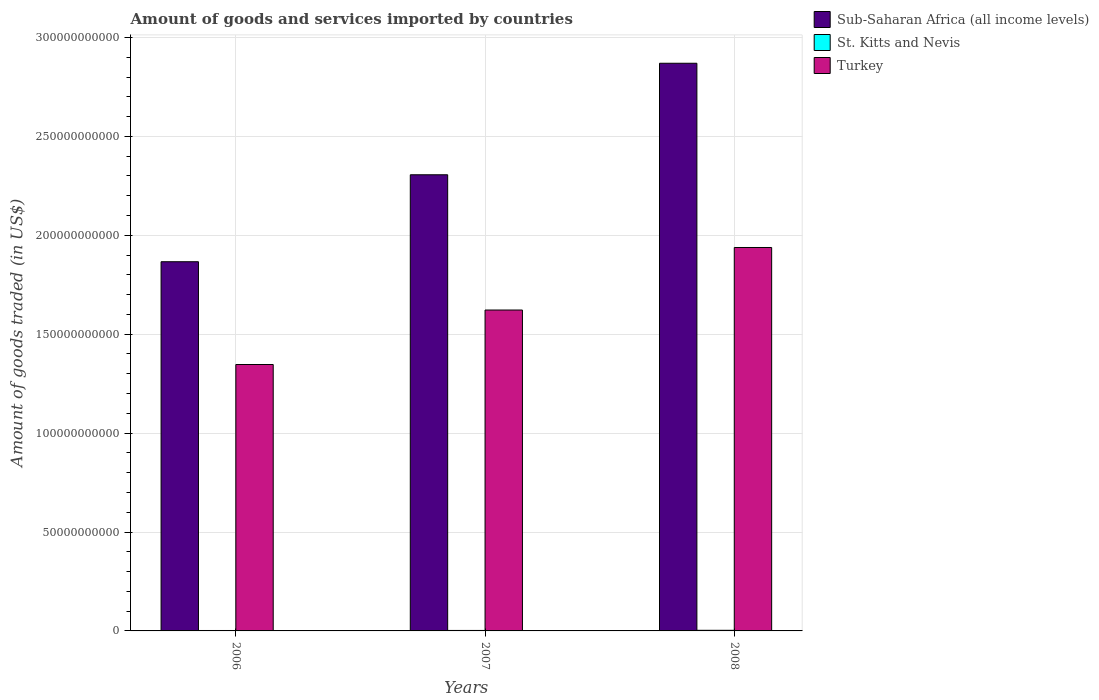How many groups of bars are there?
Give a very brief answer. 3. Are the number of bars per tick equal to the number of legend labels?
Offer a terse response. Yes. Are the number of bars on each tick of the X-axis equal?
Ensure brevity in your answer.  Yes. How many bars are there on the 3rd tick from the right?
Ensure brevity in your answer.  3. What is the label of the 3rd group of bars from the left?
Your response must be concise. 2008. What is the total amount of goods and services imported in Turkey in 2006?
Your answer should be very brief. 1.35e+11. Across all years, what is the maximum total amount of goods and services imported in Sub-Saharan Africa (all income levels)?
Keep it short and to the point. 2.87e+11. Across all years, what is the minimum total amount of goods and services imported in St. Kitts and Nevis?
Make the answer very short. 2.20e+08. In which year was the total amount of goods and services imported in St. Kitts and Nevis minimum?
Provide a short and direct response. 2006. What is the total total amount of goods and services imported in Turkey in the graph?
Your answer should be compact. 4.91e+11. What is the difference between the total amount of goods and services imported in St. Kitts and Nevis in 2006 and that in 2007?
Give a very brief answer. -2.34e+07. What is the difference between the total amount of goods and services imported in St. Kitts and Nevis in 2008 and the total amount of goods and services imported in Sub-Saharan Africa (all income levels) in 2006?
Your answer should be compact. -1.86e+11. What is the average total amount of goods and services imported in St. Kitts and Nevis per year?
Offer a very short reply. 2.58e+08. In the year 2006, what is the difference between the total amount of goods and services imported in St. Kitts and Nevis and total amount of goods and services imported in Turkey?
Make the answer very short. -1.34e+11. What is the ratio of the total amount of goods and services imported in St. Kitts and Nevis in 2007 to that in 2008?
Offer a very short reply. 0.78. Is the difference between the total amount of goods and services imported in St. Kitts and Nevis in 2007 and 2008 greater than the difference between the total amount of goods and services imported in Turkey in 2007 and 2008?
Provide a succinct answer. Yes. What is the difference between the highest and the second highest total amount of goods and services imported in Sub-Saharan Africa (all income levels)?
Ensure brevity in your answer.  5.64e+1. What is the difference between the highest and the lowest total amount of goods and services imported in Sub-Saharan Africa (all income levels)?
Your answer should be compact. 1.00e+11. What does the 2nd bar from the left in 2006 represents?
Keep it short and to the point. St. Kitts and Nevis. What does the 2nd bar from the right in 2006 represents?
Make the answer very short. St. Kitts and Nevis. How many bars are there?
Your answer should be compact. 9. How many years are there in the graph?
Give a very brief answer. 3. Does the graph contain any zero values?
Your response must be concise. No. Does the graph contain grids?
Offer a very short reply. Yes. Where does the legend appear in the graph?
Make the answer very short. Top right. How many legend labels are there?
Ensure brevity in your answer.  3. What is the title of the graph?
Your answer should be very brief. Amount of goods and services imported by countries. What is the label or title of the Y-axis?
Keep it short and to the point. Amount of goods traded (in US$). What is the Amount of goods traded (in US$) of Sub-Saharan Africa (all income levels) in 2006?
Your response must be concise. 1.87e+11. What is the Amount of goods traded (in US$) of St. Kitts and Nevis in 2006?
Ensure brevity in your answer.  2.20e+08. What is the Amount of goods traded (in US$) of Turkey in 2006?
Give a very brief answer. 1.35e+11. What is the Amount of goods traded (in US$) of Sub-Saharan Africa (all income levels) in 2007?
Provide a succinct answer. 2.31e+11. What is the Amount of goods traded (in US$) of St. Kitts and Nevis in 2007?
Provide a short and direct response. 2.43e+08. What is the Amount of goods traded (in US$) of Turkey in 2007?
Offer a terse response. 1.62e+11. What is the Amount of goods traded (in US$) in Sub-Saharan Africa (all income levels) in 2008?
Keep it short and to the point. 2.87e+11. What is the Amount of goods traded (in US$) of St. Kitts and Nevis in 2008?
Ensure brevity in your answer.  3.12e+08. What is the Amount of goods traded (in US$) in Turkey in 2008?
Offer a terse response. 1.94e+11. Across all years, what is the maximum Amount of goods traded (in US$) in Sub-Saharan Africa (all income levels)?
Your response must be concise. 2.87e+11. Across all years, what is the maximum Amount of goods traded (in US$) of St. Kitts and Nevis?
Ensure brevity in your answer.  3.12e+08. Across all years, what is the maximum Amount of goods traded (in US$) of Turkey?
Provide a succinct answer. 1.94e+11. Across all years, what is the minimum Amount of goods traded (in US$) of Sub-Saharan Africa (all income levels)?
Give a very brief answer. 1.87e+11. Across all years, what is the minimum Amount of goods traded (in US$) of St. Kitts and Nevis?
Your response must be concise. 2.20e+08. Across all years, what is the minimum Amount of goods traded (in US$) in Turkey?
Your response must be concise. 1.35e+11. What is the total Amount of goods traded (in US$) in Sub-Saharan Africa (all income levels) in the graph?
Offer a terse response. 7.04e+11. What is the total Amount of goods traded (in US$) in St. Kitts and Nevis in the graph?
Offer a terse response. 7.74e+08. What is the total Amount of goods traded (in US$) of Turkey in the graph?
Provide a succinct answer. 4.91e+11. What is the difference between the Amount of goods traded (in US$) in Sub-Saharan Africa (all income levels) in 2006 and that in 2007?
Keep it short and to the point. -4.40e+1. What is the difference between the Amount of goods traded (in US$) in St. Kitts and Nevis in 2006 and that in 2007?
Your response must be concise. -2.34e+07. What is the difference between the Amount of goods traded (in US$) of Turkey in 2006 and that in 2007?
Ensure brevity in your answer.  -2.75e+1. What is the difference between the Amount of goods traded (in US$) of Sub-Saharan Africa (all income levels) in 2006 and that in 2008?
Provide a short and direct response. -1.00e+11. What is the difference between the Amount of goods traded (in US$) in St. Kitts and Nevis in 2006 and that in 2008?
Your answer should be very brief. -9.23e+07. What is the difference between the Amount of goods traded (in US$) in Turkey in 2006 and that in 2008?
Provide a succinct answer. -5.92e+1. What is the difference between the Amount of goods traded (in US$) of Sub-Saharan Africa (all income levels) in 2007 and that in 2008?
Make the answer very short. -5.64e+1. What is the difference between the Amount of goods traded (in US$) of St. Kitts and Nevis in 2007 and that in 2008?
Your answer should be compact. -6.90e+07. What is the difference between the Amount of goods traded (in US$) in Turkey in 2007 and that in 2008?
Offer a terse response. -3.16e+1. What is the difference between the Amount of goods traded (in US$) of Sub-Saharan Africa (all income levels) in 2006 and the Amount of goods traded (in US$) of St. Kitts and Nevis in 2007?
Your answer should be very brief. 1.86e+11. What is the difference between the Amount of goods traded (in US$) in Sub-Saharan Africa (all income levels) in 2006 and the Amount of goods traded (in US$) in Turkey in 2007?
Keep it short and to the point. 2.44e+1. What is the difference between the Amount of goods traded (in US$) in St. Kitts and Nevis in 2006 and the Amount of goods traded (in US$) in Turkey in 2007?
Provide a short and direct response. -1.62e+11. What is the difference between the Amount of goods traded (in US$) of Sub-Saharan Africa (all income levels) in 2006 and the Amount of goods traded (in US$) of St. Kitts and Nevis in 2008?
Your answer should be compact. 1.86e+11. What is the difference between the Amount of goods traded (in US$) in Sub-Saharan Africa (all income levels) in 2006 and the Amount of goods traded (in US$) in Turkey in 2008?
Your response must be concise. -7.20e+09. What is the difference between the Amount of goods traded (in US$) of St. Kitts and Nevis in 2006 and the Amount of goods traded (in US$) of Turkey in 2008?
Your answer should be very brief. -1.94e+11. What is the difference between the Amount of goods traded (in US$) of Sub-Saharan Africa (all income levels) in 2007 and the Amount of goods traded (in US$) of St. Kitts and Nevis in 2008?
Your answer should be very brief. 2.30e+11. What is the difference between the Amount of goods traded (in US$) in Sub-Saharan Africa (all income levels) in 2007 and the Amount of goods traded (in US$) in Turkey in 2008?
Provide a succinct answer. 3.68e+1. What is the difference between the Amount of goods traded (in US$) in St. Kitts and Nevis in 2007 and the Amount of goods traded (in US$) in Turkey in 2008?
Ensure brevity in your answer.  -1.94e+11. What is the average Amount of goods traded (in US$) in Sub-Saharan Africa (all income levels) per year?
Offer a very short reply. 2.35e+11. What is the average Amount of goods traded (in US$) in St. Kitts and Nevis per year?
Your answer should be compact. 2.58e+08. What is the average Amount of goods traded (in US$) in Turkey per year?
Your response must be concise. 1.64e+11. In the year 2006, what is the difference between the Amount of goods traded (in US$) in Sub-Saharan Africa (all income levels) and Amount of goods traded (in US$) in St. Kitts and Nevis?
Provide a short and direct response. 1.86e+11. In the year 2006, what is the difference between the Amount of goods traded (in US$) of Sub-Saharan Africa (all income levels) and Amount of goods traded (in US$) of Turkey?
Make the answer very short. 5.20e+1. In the year 2006, what is the difference between the Amount of goods traded (in US$) of St. Kitts and Nevis and Amount of goods traded (in US$) of Turkey?
Offer a very short reply. -1.34e+11. In the year 2007, what is the difference between the Amount of goods traded (in US$) of Sub-Saharan Africa (all income levels) and Amount of goods traded (in US$) of St. Kitts and Nevis?
Make the answer very short. 2.30e+11. In the year 2007, what is the difference between the Amount of goods traded (in US$) of Sub-Saharan Africa (all income levels) and Amount of goods traded (in US$) of Turkey?
Give a very brief answer. 6.84e+1. In the year 2007, what is the difference between the Amount of goods traded (in US$) in St. Kitts and Nevis and Amount of goods traded (in US$) in Turkey?
Provide a succinct answer. -1.62e+11. In the year 2008, what is the difference between the Amount of goods traded (in US$) of Sub-Saharan Africa (all income levels) and Amount of goods traded (in US$) of St. Kitts and Nevis?
Provide a short and direct response. 2.87e+11. In the year 2008, what is the difference between the Amount of goods traded (in US$) of Sub-Saharan Africa (all income levels) and Amount of goods traded (in US$) of Turkey?
Ensure brevity in your answer.  9.31e+1. In the year 2008, what is the difference between the Amount of goods traded (in US$) of St. Kitts and Nevis and Amount of goods traded (in US$) of Turkey?
Offer a very short reply. -1.94e+11. What is the ratio of the Amount of goods traded (in US$) in Sub-Saharan Africa (all income levels) in 2006 to that in 2007?
Ensure brevity in your answer.  0.81. What is the ratio of the Amount of goods traded (in US$) in St. Kitts and Nevis in 2006 to that in 2007?
Keep it short and to the point. 0.9. What is the ratio of the Amount of goods traded (in US$) of Turkey in 2006 to that in 2007?
Ensure brevity in your answer.  0.83. What is the ratio of the Amount of goods traded (in US$) of Sub-Saharan Africa (all income levels) in 2006 to that in 2008?
Provide a short and direct response. 0.65. What is the ratio of the Amount of goods traded (in US$) in St. Kitts and Nevis in 2006 to that in 2008?
Make the answer very short. 0.7. What is the ratio of the Amount of goods traded (in US$) of Turkey in 2006 to that in 2008?
Your answer should be very brief. 0.69. What is the ratio of the Amount of goods traded (in US$) of Sub-Saharan Africa (all income levels) in 2007 to that in 2008?
Keep it short and to the point. 0.8. What is the ratio of the Amount of goods traded (in US$) in St. Kitts and Nevis in 2007 to that in 2008?
Your answer should be compact. 0.78. What is the ratio of the Amount of goods traded (in US$) in Turkey in 2007 to that in 2008?
Provide a short and direct response. 0.84. What is the difference between the highest and the second highest Amount of goods traded (in US$) of Sub-Saharan Africa (all income levels)?
Offer a very short reply. 5.64e+1. What is the difference between the highest and the second highest Amount of goods traded (in US$) in St. Kitts and Nevis?
Provide a succinct answer. 6.90e+07. What is the difference between the highest and the second highest Amount of goods traded (in US$) in Turkey?
Keep it short and to the point. 3.16e+1. What is the difference between the highest and the lowest Amount of goods traded (in US$) in Sub-Saharan Africa (all income levels)?
Make the answer very short. 1.00e+11. What is the difference between the highest and the lowest Amount of goods traded (in US$) of St. Kitts and Nevis?
Your answer should be very brief. 9.23e+07. What is the difference between the highest and the lowest Amount of goods traded (in US$) of Turkey?
Your response must be concise. 5.92e+1. 